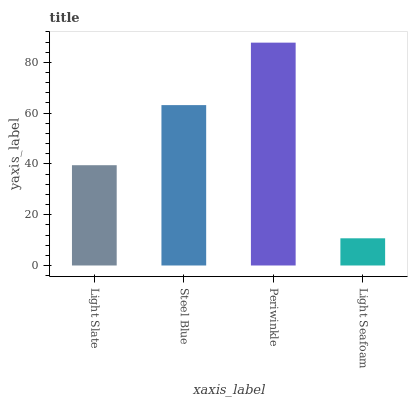Is Light Seafoam the minimum?
Answer yes or no. Yes. Is Periwinkle the maximum?
Answer yes or no. Yes. Is Steel Blue the minimum?
Answer yes or no. No. Is Steel Blue the maximum?
Answer yes or no. No. Is Steel Blue greater than Light Slate?
Answer yes or no. Yes. Is Light Slate less than Steel Blue?
Answer yes or no. Yes. Is Light Slate greater than Steel Blue?
Answer yes or no. No. Is Steel Blue less than Light Slate?
Answer yes or no. No. Is Steel Blue the high median?
Answer yes or no. Yes. Is Light Slate the low median?
Answer yes or no. Yes. Is Periwinkle the high median?
Answer yes or no. No. Is Light Seafoam the low median?
Answer yes or no. No. 